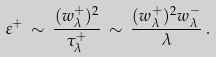<formula> <loc_0><loc_0><loc_500><loc_500>\varepsilon ^ { + } \, \sim \, \frac { ( w _ { \lambda } ^ { + } ) ^ { 2 } } { \tau _ { \lambda } ^ { + } } \, \sim \, \frac { ( w _ { \lambda } ^ { + } ) ^ { 2 } w _ { \lambda } ^ { - } } { \lambda } \, .</formula> 